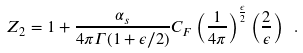<formula> <loc_0><loc_0><loc_500><loc_500>Z _ { 2 } = 1 + { \frac { \alpha _ { s } } { 4 \pi \Gamma ( 1 + \epsilon / 2 ) } } C _ { F } \left ( { \frac { 1 } { 4 \pi } } \right ) ^ { { \frac { \epsilon } { 2 } } } \left ( { \frac { 2 } { \epsilon } } \right ) \ .</formula> 